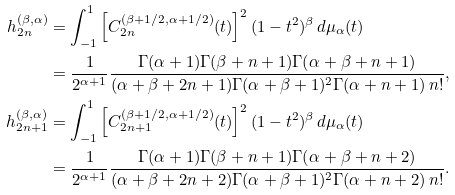Convert formula to latex. <formula><loc_0><loc_0><loc_500><loc_500>h _ { 2 n } ^ { ( \beta , \alpha ) } & = \int _ { - 1 } ^ { 1 } \left [ C _ { 2 n } ^ { ( \beta + 1 / 2 , \alpha + 1 / 2 ) } ( t ) \right ] ^ { 2 } ( 1 - t ^ { 2 } ) ^ { \beta } \, d \mu _ { \alpha } ( t ) \\ & = \frac { 1 } { 2 ^ { \alpha + 1 } } \frac { \Gamma ( \alpha + 1 ) \Gamma ( \beta + n + 1 ) \Gamma ( \alpha + \beta + n + 1 ) } { ( \alpha + \beta + 2 n + 1 ) \Gamma ( \alpha + \beta + 1 ) ^ { 2 } \Gamma ( \alpha + n + 1 ) \, n ! } , \\ h _ { 2 n + 1 } ^ { ( \beta , \alpha ) } & = \int _ { - 1 } ^ { 1 } \left [ C _ { 2 n + 1 } ^ { ( \beta + 1 / 2 , \alpha + 1 / 2 ) } ( t ) \right ] ^ { 2 } ( 1 - t ^ { 2 } ) ^ { \beta } \, d \mu _ { \alpha } ( t ) \\ & = \frac { 1 } { 2 ^ { \alpha + 1 } } \frac { \Gamma ( \alpha + 1 ) \Gamma ( \beta + n + 1 ) \Gamma ( \alpha + \beta + n + 2 ) } { ( \alpha + \beta + 2 n + 2 ) \Gamma ( \alpha + \beta + 1 ) ^ { 2 } \Gamma ( \alpha + n + 2 ) \, n ! } .</formula> 